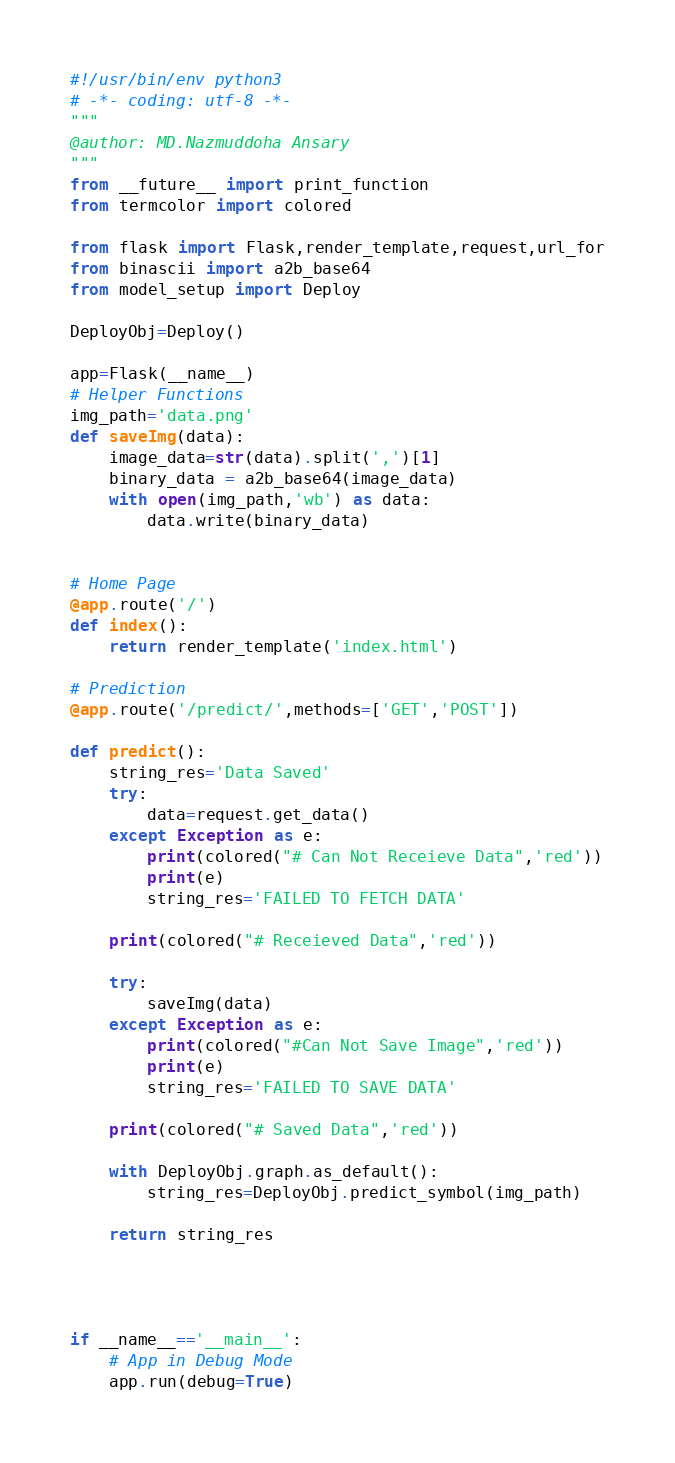<code> <loc_0><loc_0><loc_500><loc_500><_Python_>#!/usr/bin/env python3
# -*- coding: utf-8 -*-
"""
@author: MD.Nazmuddoha Ansary
"""
from __future__ import print_function
from termcolor import colored

from flask import Flask,render_template,request,url_for
from binascii import a2b_base64
from model_setup import Deploy

DeployObj=Deploy()
    
app=Flask(__name__)
# Helper Functions
img_path='data.png'
def saveImg(data):
    image_data=str(data).split(',')[1]
    binary_data = a2b_base64(image_data)
    with open(img_path,'wb') as data:
        data.write(binary_data)


# Home Page
@app.route('/')
def index():
    return render_template('index.html')

# Prediction
@app.route('/predict/',methods=['GET','POST'])

def predict():
    string_res='Data Saved'
    try:
        data=request.get_data()
    except Exception as e: 
        print(colored("# Can Not Receieve Data",'red'))
        print(e)
        string_res='FAILED TO FETCH DATA'
    
    print(colored("# Receieved Data",'red'))

    try:
        saveImg(data)
    except Exception as e: 
        print(colored("#Can Not Save Image",'red'))
        print(e)
        string_res='FAILED TO SAVE DATA'
    
    print(colored("# Saved Data",'red'))
    
    with DeployObj.graph.as_default():
        string_res=DeployObj.predict_symbol(img_path)
    
    return string_res




if __name__=='__main__':
    # App in Debug Mode    
    app.run(debug=True)
</code> 